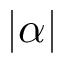Convert formula to latex. <formula><loc_0><loc_0><loc_500><loc_500>| \alpha |</formula> 